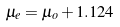<formula> <loc_0><loc_0><loc_500><loc_500>\mu _ { e } = \mu _ { o } + 1 . 1 2 4</formula> 